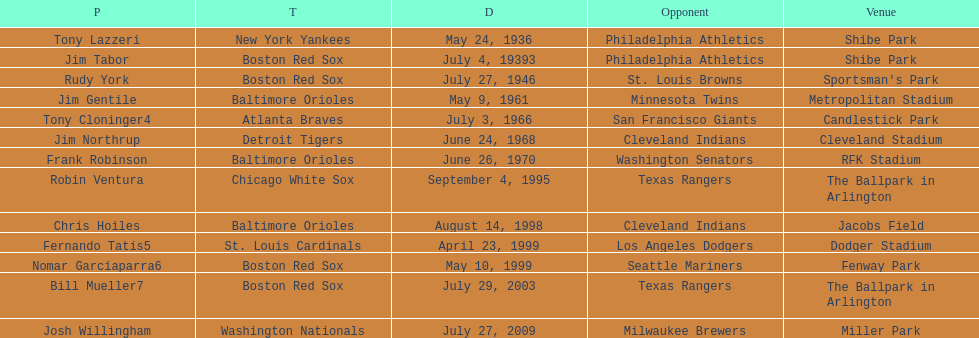Who is the first major league hitter to hit two grand slams in one game? Tony Lazzeri. 